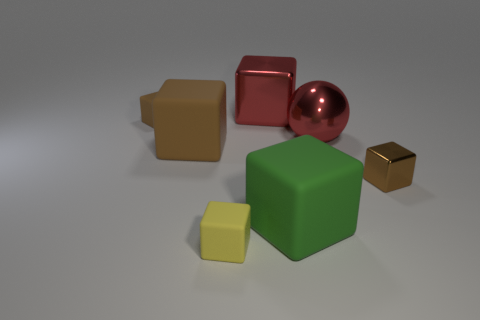Does the metal thing that is in front of the big shiny ball have the same size as the green thing that is in front of the brown metal thing?
Your response must be concise. No. Do the yellow matte cube and the object right of the red metal sphere have the same size?
Give a very brief answer. Yes. What is the size of the yellow rubber object?
Give a very brief answer. Small. There is a tiny object that is the same material as the big sphere; what is its color?
Ensure brevity in your answer.  Brown. How many spheres are the same material as the small yellow block?
Your response must be concise. 0. How many objects are brown metal objects or shiny blocks that are left of the green object?
Provide a short and direct response. 2. Is the material of the cube to the right of the ball the same as the green block?
Offer a terse response. No. The metallic thing that is the same size as the red metallic cube is what color?
Your answer should be compact. Red. Is there another brown rubber object of the same shape as the large brown matte object?
Provide a short and direct response. Yes. There is a tiny matte block to the right of the tiny rubber cube that is behind the small brown block that is on the right side of the yellow matte cube; what is its color?
Your answer should be very brief. Yellow. 